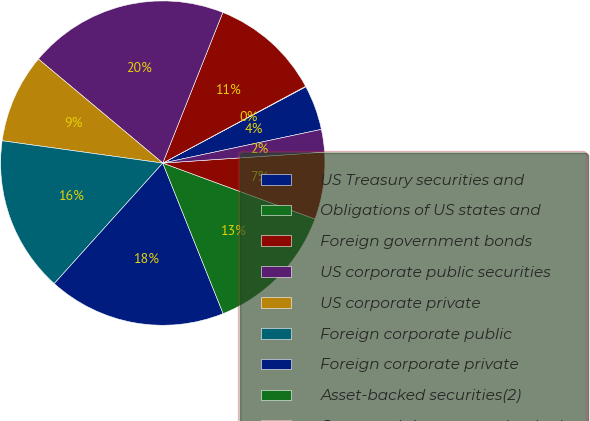<chart> <loc_0><loc_0><loc_500><loc_500><pie_chart><fcel>US Treasury securities and<fcel>Obligations of US states and<fcel>Foreign government bonds<fcel>US corporate public securities<fcel>US corporate private<fcel>Foreign corporate public<fcel>Foreign corporate private<fcel>Asset-backed securities(2)<fcel>Commercial mortgage-backed<fcel>Residential mortgage-backed<nl><fcel>4.47%<fcel>0.05%<fcel>11.11%<fcel>19.95%<fcel>8.89%<fcel>15.53%<fcel>17.74%<fcel>13.32%<fcel>6.68%<fcel>2.26%<nl></chart> 